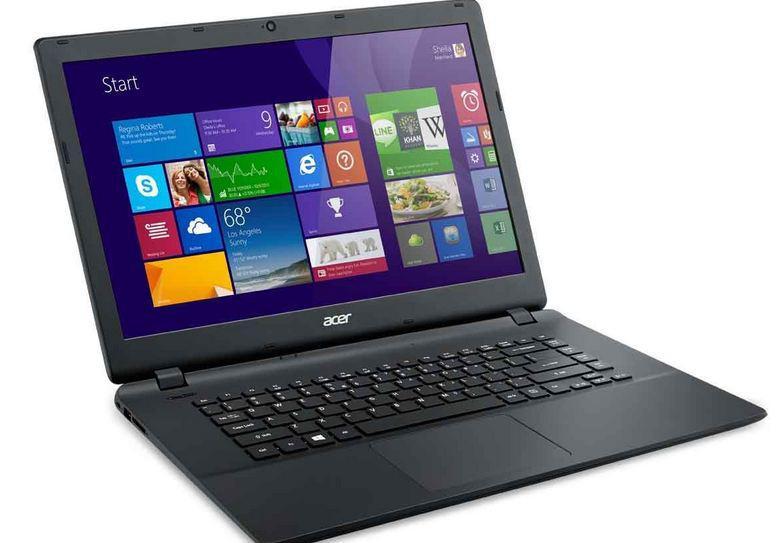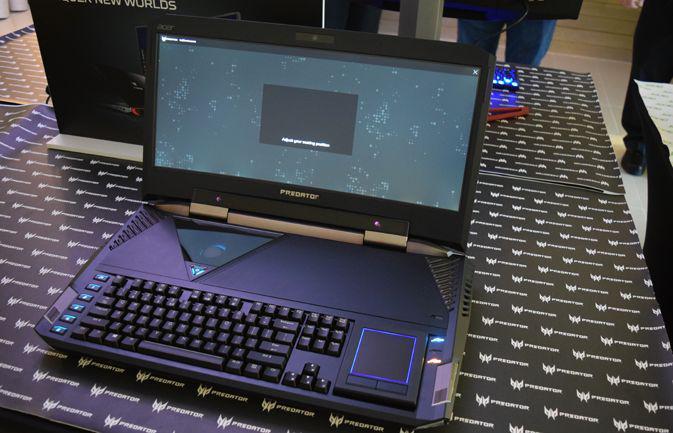The first image is the image on the left, the second image is the image on the right. Assess this claim about the two images: "All laptops are displayed on white backgrounds, and the laptop on the right shows yellow and green sections divided diagonally on the screen.". Correct or not? Answer yes or no. No. The first image is the image on the left, the second image is the image on the right. For the images displayed, is the sentence "The right image features a black laptop computer with a green and yellow background visible on its screen" factually correct? Answer yes or no. No. 